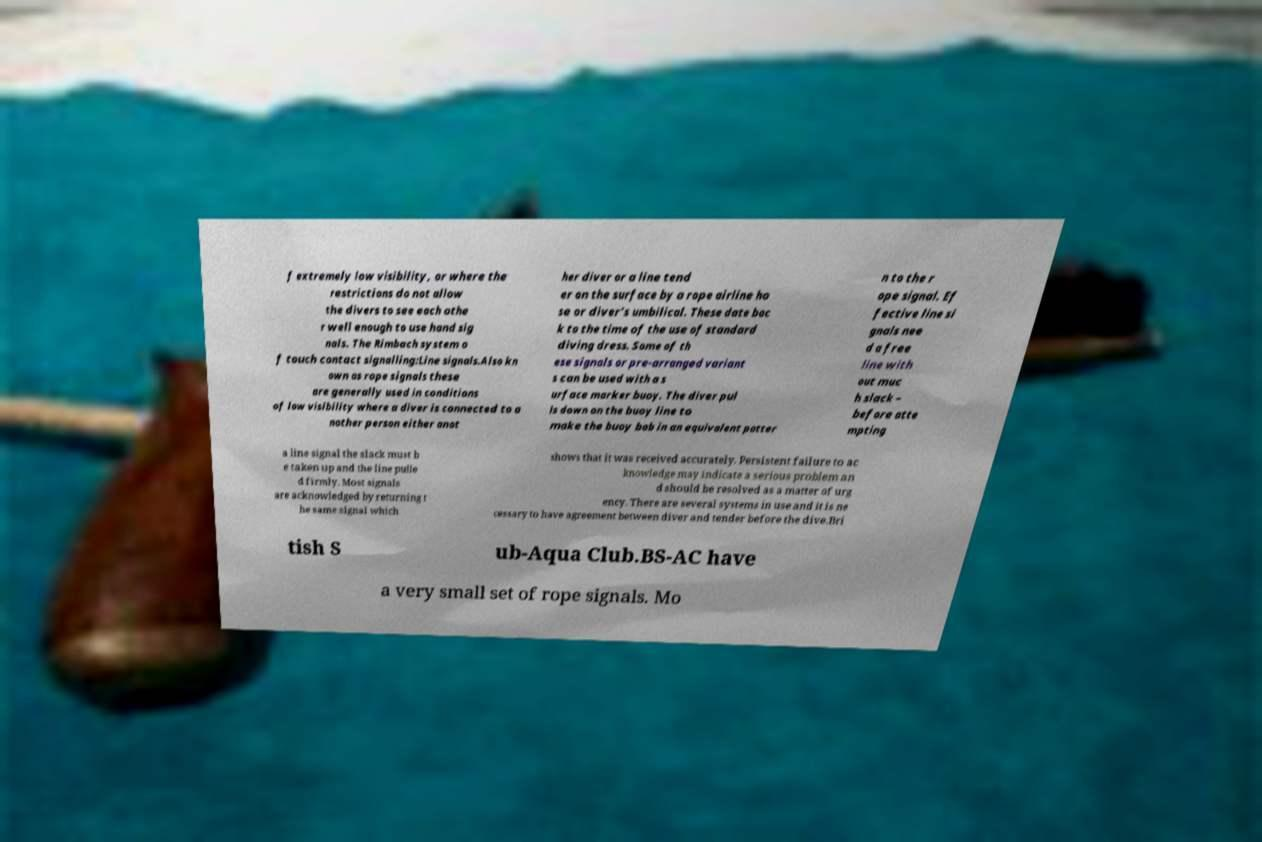Can you accurately transcribe the text from the provided image for me? f extremely low visibility, or where the restrictions do not allow the divers to see each othe r well enough to use hand sig nals. The Rimbach system o f touch contact signalling:Line signals.Also kn own as rope signals these are generally used in conditions of low visibility where a diver is connected to a nother person either anot her diver or a line tend er on the surface by a rope airline ho se or diver's umbilical. These date bac k to the time of the use of standard diving dress. Some of th ese signals or pre-arranged variant s can be used with a s urface marker buoy. The diver pul ls down on the buoy line to make the buoy bob in an equivalent patter n to the r ope signal. Ef fective line si gnals nee d a free line with out muc h slack – before atte mpting a line signal the slack must b e taken up and the line pulle d firmly. Most signals are acknowledged by returning t he same signal which shows that it was received accurately. Persistent failure to ac knowledge may indicate a serious problem an d should be resolved as a matter of urg ency. There are several systems in use and it is ne cessary to have agreement between diver and tender before the dive.Bri tish S ub-Aqua Club.BS-AC have a very small set of rope signals. Mo 